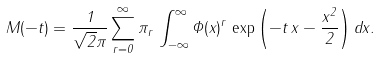<formula> <loc_0><loc_0><loc_500><loc_500>M ( - t ) = \frac { 1 } { \sqrt { 2 } \pi } \sum _ { r = 0 } ^ { \infty } \pi _ { r } \, \int _ { - \infty } ^ { \infty } \Phi ( x ) ^ { r } \, \exp \left ( - t \, x - \frac { x ^ { 2 } } { 2 } \right ) d x .</formula> 